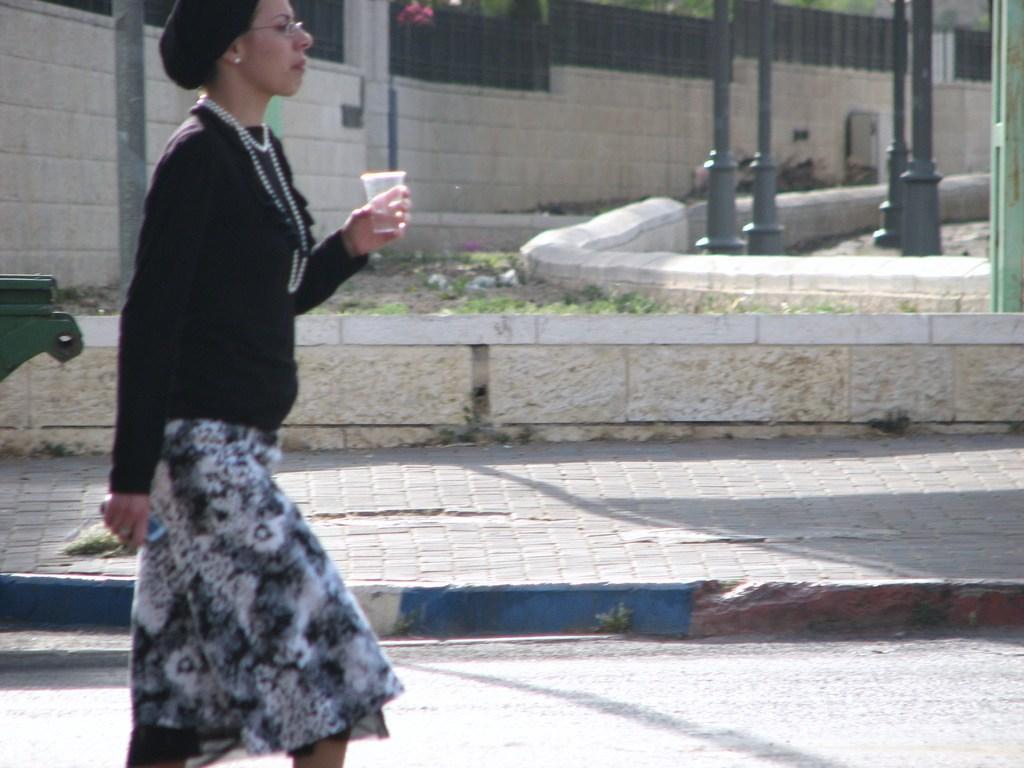How would you summarize this image in a sentence or two? In this picture, we can see some plants, flowers, a person holding glass, road, path, poles, wall with fencing and we can see some object on the left side 